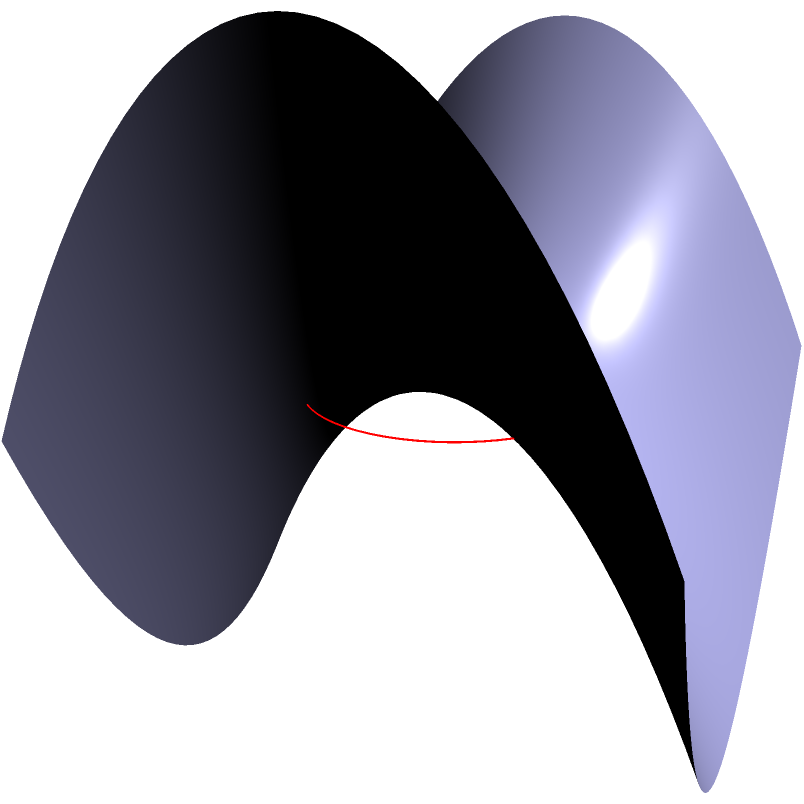On a saddle-shaped surface described by the equation $z = x^2 - y^2$, a circle with radius 1 is drawn on the $xy$-plane centered at the origin. Calculate the area of this circle as projected onto the saddle surface. To solve this problem, we need to follow these steps:

1) The area of a surface in 3D space is given by the surface integral:

   $$ A = \iint_D \sqrt{1 + \left(\frac{\partial z}{\partial x}\right)^2 + \left(\frac{\partial z}{\partial y}\right)^2} \, dA $$

2) For our saddle surface $z = x^2 - y^2$, we have:

   $$ \frac{\partial z}{\partial x} = 2x $$
   $$ \frac{\partial z}{\partial y} = -2y $$

3) Substituting these into our area formula:

   $$ A = \iint_D \sqrt{1 + (2x)^2 + (-2y)^2} \, dA $$
   $$ A = \iint_D \sqrt{1 + 4x^2 + 4y^2} \, dA $$

4) The circle on the xy-plane is described by $x^2 + y^2 \leq 1$. We can use polar coordinates to simplify our integral:

   $$ A = \int_0^{2\pi} \int_0^1 \sqrt{1 + 4r^2} \, r \, dr \, d\theta $$

5) The $\theta$ integral is straightforward as the integrand doesn't depend on $\theta$:

   $$ A = 2\pi \int_0^1 \sqrt{1 + 4r^2} \, r \, dr $$

6) To solve this integral, we can use the substitution $u = 1 + 4r^2$, $du = 8r \, dr$:

   $$ A = \frac{\pi}{4} \int_1^5 \sqrt{u} \, du $$

7) Evaluating this integral:

   $$ A = \frac{\pi}{4} \left[\frac{2}{3}u^{3/2}\right]_1^5 $$
   $$ A = \frac{\pi}{6} (5\sqrt{5} - 1) $$

Therefore, the area of the circle as projected onto the saddle surface is $\frac{\pi}{6} (5\sqrt{5} - 1)$.
Answer: $\frac{\pi}{6} (5\sqrt{5} - 1)$ 